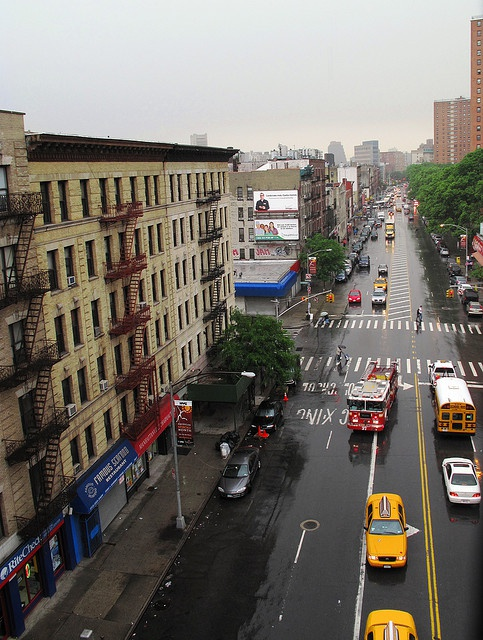Describe the objects in this image and their specific colors. I can see car in white, black, gray, and darkgray tones, car in white, orange, black, red, and gray tones, truck in white, black, lightgray, darkgray, and gray tones, bus in white, whitesmoke, black, red, and maroon tones, and car in white, black, gray, and darkgray tones in this image. 